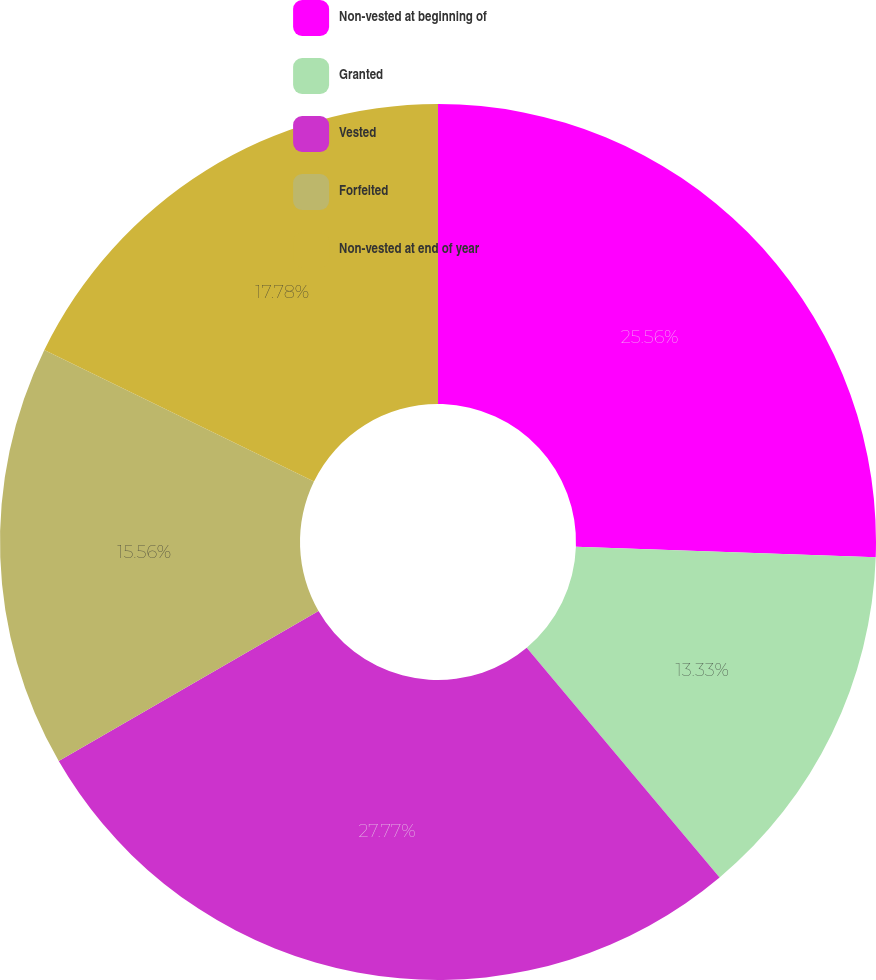<chart> <loc_0><loc_0><loc_500><loc_500><pie_chart><fcel>Non-vested at beginning of<fcel>Granted<fcel>Vested<fcel>Forfeited<fcel>Non-vested at end of year<nl><fcel>25.56%<fcel>13.33%<fcel>27.78%<fcel>15.56%<fcel>17.78%<nl></chart> 